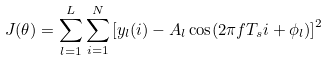<formula> <loc_0><loc_0><loc_500><loc_500>J ( \theta ) = \sum _ { l = 1 } ^ { L } \sum _ { i = 1 } ^ { N } \left [ y _ { l } ( i ) - A _ { l } \cos ( 2 \pi f T _ { s } i + \phi _ { l } ) \right ] ^ { 2 }</formula> 